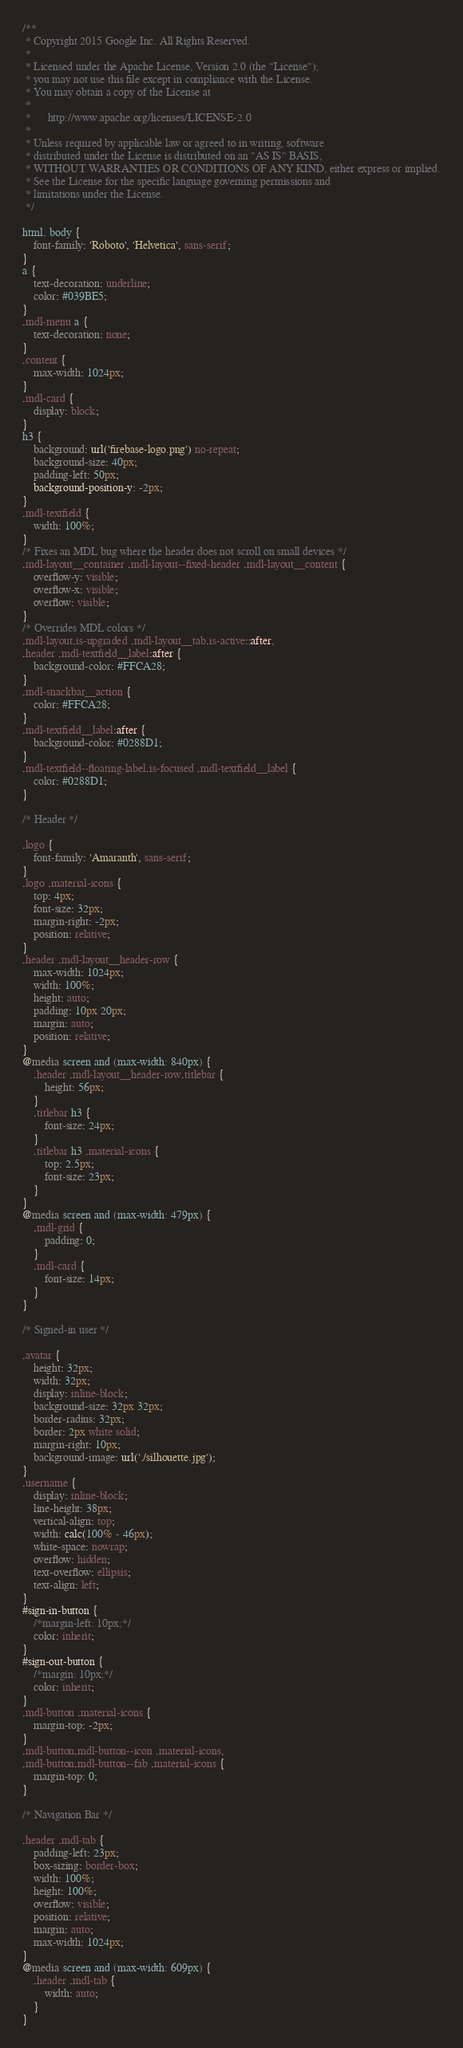Convert code to text. <code><loc_0><loc_0><loc_500><loc_500><_CSS_>/**
 * Copyright 2015 Google Inc. All Rights Reserved.
 *
 * Licensed under the Apache License, Version 2.0 (the "License");
 * you may not use this file except in compliance with the License.
 * You may obtain a copy of the License at
 *
 *      http://www.apache.org/licenses/LICENSE-2.0
 *
 * Unless required by applicable law or agreed to in writing, software
 * distributed under the License is distributed on an "AS IS" BASIS,
 * WITHOUT WARRANTIES OR CONDITIONS OF ANY KIND, either express or implied.
 * See the License for the specific language governing permissions and
 * limitations under the License.
 */

html, body {
    font-family: 'Roboto', 'Helvetica', sans-serif;
}
a {
    text-decoration: underline;
    color: #039BE5;
}
.mdl-menu a {
    text-decoration: none;
}
.content {
    max-width: 1024px;
}
.mdl-card {
    display: block;
}
h3 {
    background: url('firebase-logo.png') no-repeat;
    background-size: 40px;
    padding-left: 50px;
    background-position-y: -2px;
}
.mdl-textfield {
    width: 100%;
}
/* Fixes an MDL bug where the header does not scroll on small devices */
.mdl-layout__container .mdl-layout--fixed-header .mdl-layout__content {
    overflow-y: visible;
    overflow-x: visible;
    overflow: visible;
}
/* Overrides MDL colors */
.mdl-layout.is-upgraded .mdl-layout__tab.is-active::after,
.header .mdl-textfield__label:after {
    background-color: #FFCA28;
}
.mdl-snackbar__action {
    color: #FFCA28;
}
.mdl-textfield__label:after {
    background-color: #0288D1;
}
.mdl-textfield--floating-label.is-focused .mdl-textfield__label {
    color: #0288D1;
}

/* Header */

.logo {
    font-family: 'Amaranth', sans-serif;
}
.logo .material-icons {
    top: 4px;
    font-size: 32px;
    margin-right: -2px;
    position: relative;
}
.header .mdl-layout__header-row {
    max-width: 1024px;
    width: 100%;
    height: auto;
    padding: 10px 20px;
    margin: auto;
    position: relative;
}
@media screen and (max-width: 840px) {
    .header .mdl-layout__header-row.titlebar {
        height: 56px;
    }
    .titlebar h3 {
        font-size: 24px;
    }
    .titlebar h3 .material-icons {
        top: 2.5px;
        font-size: 23px;
    }
}
@media screen and (max-width: 479px) {
    .mdl-grid {
        padding: 0;
    }
    .mdl-card {
        font-size: 14px;
    }
}

/* Signed-in user */

.avatar {
    height: 32px;
    width: 32px;
    display: inline-block;
    background-size: 32px 32px;
    border-radius: 32px;
    border: 2px white solid;
    margin-right: 10px;
    background-image: url('./silhouette.jpg');
}
.username {
    display: inline-block;
    line-height: 38px;
    vertical-align: top;
    width: calc(100% - 46px);
    white-space: nowrap;
    overflow: hidden;
    text-overflow: ellipsis;
    text-align: left;
}
#sign-in-button {
    /*margin-left: 10px;*/
    color: inherit;
}
#sign-out-button {
    /*margin: 10px;*/
    color: inherit;
}
.mdl-button .material-icons {
    margin-top: -2px;
}
.mdl-button.mdl-button--icon .material-icons,
.mdl-button.mdl-button--fab .material-icons {
    margin-top: 0;
}

/* Navigation Bar */

.header .mdl-tab {
    padding-left: 23px;
    box-sizing: border-box;
    width: 100%;
    height: 100%;
    overflow: visible;
    position: relative;
    margin: auto;
    max-width: 1024px;
}
@media screen and (max-width: 609px) {
    .header .mdl-tab {
        width: auto;
    }
}</code> 